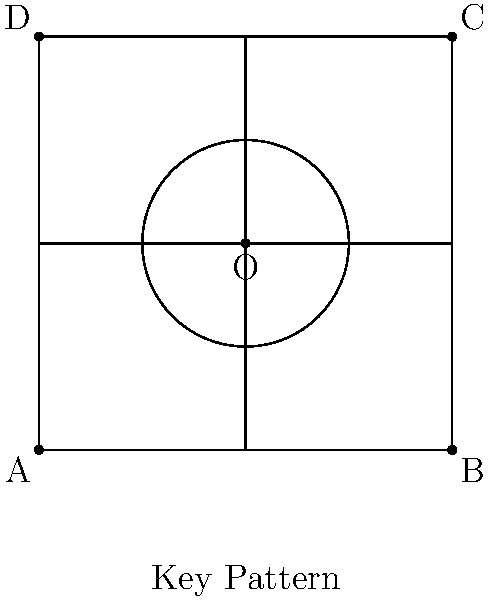In the context of cryptographic key generation, consider the geometric shape shown above. If this pattern represents a base key, how many unique keys can be generated using only reflection symmetry operations? Assume that rotations and translations are not allowed, and that the circle at the center must remain fixed. To solve this problem, we need to follow these steps:

1) First, identify the lines of reflection symmetry in the shape:
   - There are two diagonal lines of symmetry (from corner to corner)
   - There are two lines of symmetry along the midpoints of opposite sides

2) Each line of symmetry can create one new configuration by reflecting the entire shape across it.

3) Count the number of unique configurations:
   - The original configuration: 1
   - Reflections across the 4 lines of symmetry: 4

4) The total number of unique keys is the sum of these: 1 + 4 = 5

5) In terms of cryptography, this means that from a single base key pattern, we can generate 5 unique keys using reflection symmetry.

6) It's worth noting that in actual cryptographic applications, this geometric approach would be translated into binary or numerical representations, where each unique configuration would correspond to a distinct key.

7) The fixed circle at the center ensures that all reflections maintain a consistent reference point, which could be crucial for key alignment or validation in a cryptographic system.
Answer: 5 unique keys 